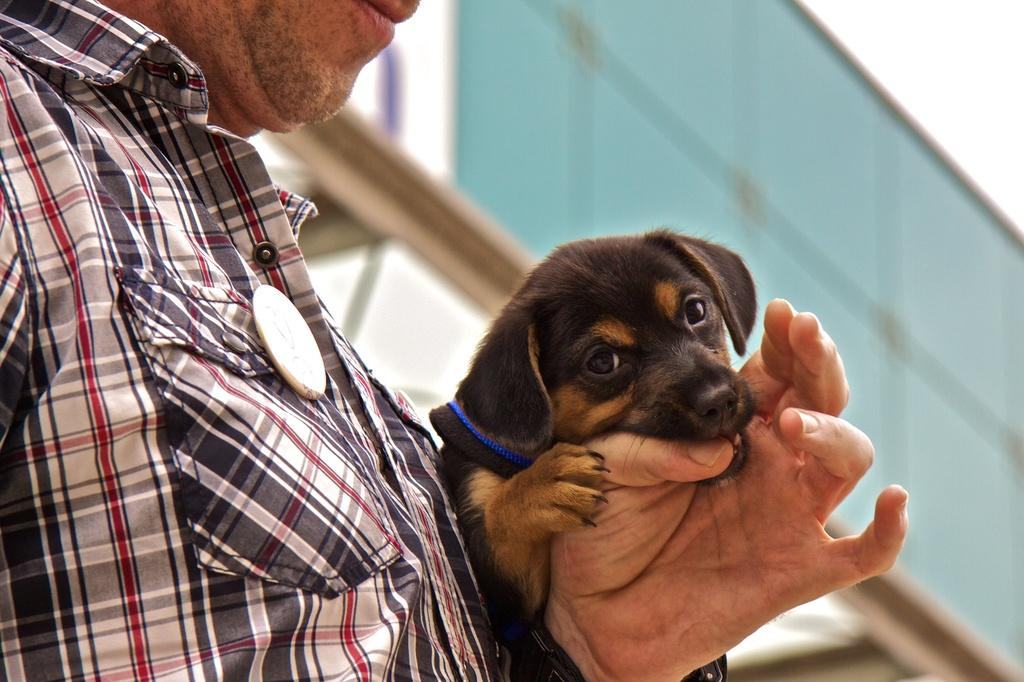What is present in the image? There is a man in the image. What is the man holding in the image? The man is holding a dog. Can you describe the position of the dog in relation to the man? The dog is on the man's hand. What type of watch is the man wearing in the image? There is no watch visible in the image. Is the man attempting to catch any spiders in the image? There is no indication of spiders or any attempt to catch them in the image. 